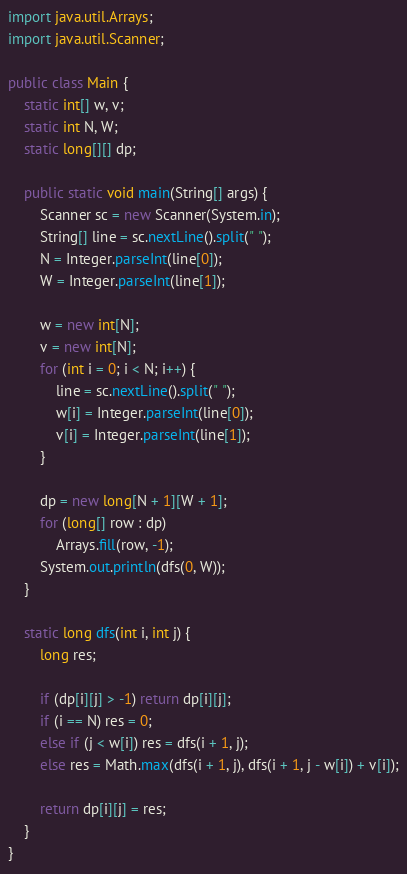<code> <loc_0><loc_0><loc_500><loc_500><_Java_>import java.util.Arrays;
import java.util.Scanner;

public class Main {
	static int[] w, v;
	static int N, W;
	static long[][] dp;

	public static void main(String[] args) {
		Scanner sc = new Scanner(System.in);
		String[] line = sc.nextLine().split(" ");
		N = Integer.parseInt(line[0]);
		W = Integer.parseInt(line[1]);

		w = new int[N];
		v = new int[N];
		for (int i = 0; i < N; i++) {
			line = sc.nextLine().split(" ");
			w[i] = Integer.parseInt(line[0]);
			v[i] = Integer.parseInt(line[1]);
		}

		dp = new long[N + 1][W + 1];
		for (long[] row : dp)
			Arrays.fill(row, -1);
		System.out.println(dfs(0, W));
	}

	static long dfs(int i, int j) {
		long res;

		if (dp[i][j] > -1) return dp[i][j];
		if (i == N) res = 0;
		else if (j < w[i]) res = dfs(i + 1, j);
		else res = Math.max(dfs(i + 1, j), dfs(i + 1, j - w[i]) + v[i]);

		return dp[i][j] = res;
	}
}</code> 